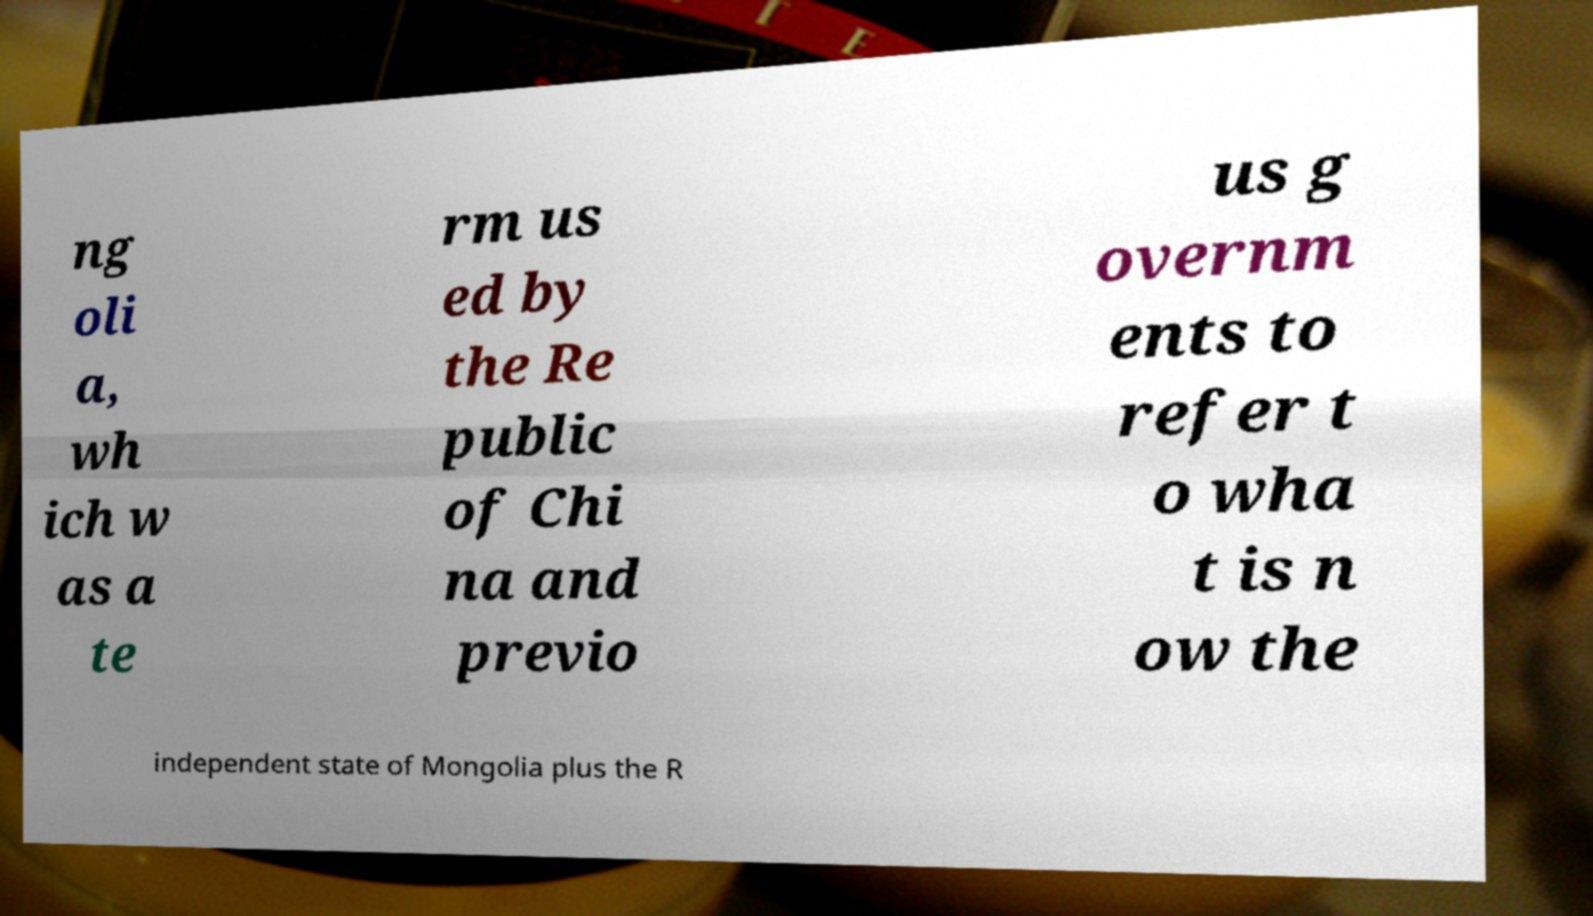I need the written content from this picture converted into text. Can you do that? ng oli a, wh ich w as a te rm us ed by the Re public of Chi na and previo us g overnm ents to refer t o wha t is n ow the independent state of Mongolia plus the R 